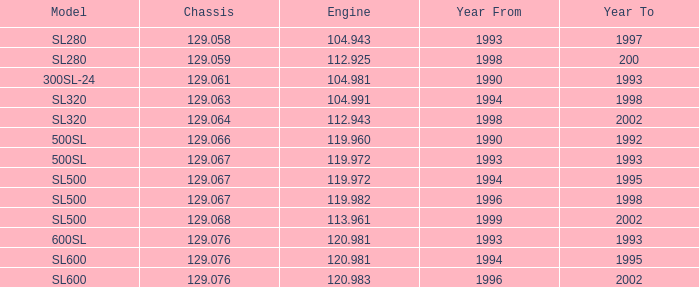972 and a chassis under 12 None. 